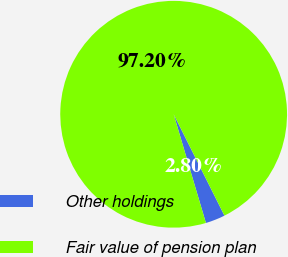Convert chart to OTSL. <chart><loc_0><loc_0><loc_500><loc_500><pie_chart><fcel>Other holdings<fcel>Fair value of pension plan<nl><fcel>2.8%<fcel>97.2%<nl></chart> 